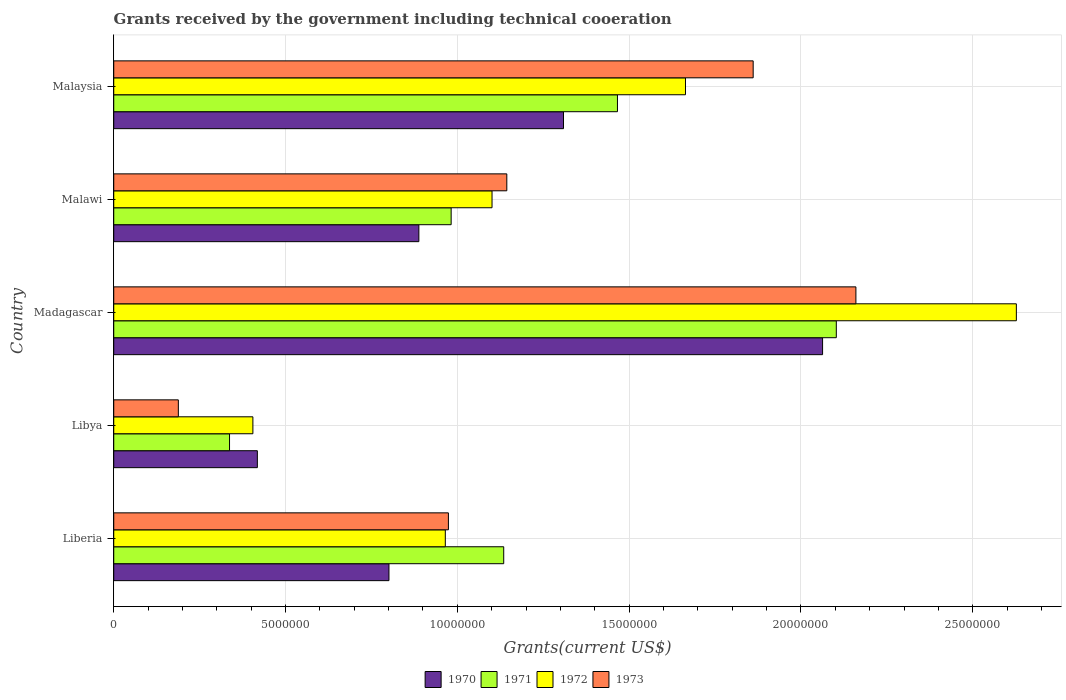Are the number of bars on each tick of the Y-axis equal?
Make the answer very short. Yes. How many bars are there on the 1st tick from the top?
Offer a very short reply. 4. How many bars are there on the 5th tick from the bottom?
Offer a very short reply. 4. What is the label of the 2nd group of bars from the top?
Your response must be concise. Malawi. What is the total grants received by the government in 1970 in Madagascar?
Provide a short and direct response. 2.06e+07. Across all countries, what is the maximum total grants received by the government in 1971?
Your answer should be very brief. 2.10e+07. Across all countries, what is the minimum total grants received by the government in 1972?
Offer a very short reply. 4.05e+06. In which country was the total grants received by the government in 1970 maximum?
Offer a very short reply. Madagascar. In which country was the total grants received by the government in 1972 minimum?
Offer a terse response. Libya. What is the total total grants received by the government in 1970 in the graph?
Make the answer very short. 5.48e+07. What is the difference between the total grants received by the government in 1971 in Liberia and that in Malaysia?
Provide a short and direct response. -3.31e+06. What is the difference between the total grants received by the government in 1971 in Malaysia and the total grants received by the government in 1973 in Liberia?
Offer a terse response. 4.92e+06. What is the average total grants received by the government in 1973 per country?
Your answer should be very brief. 1.27e+07. What is the difference between the total grants received by the government in 1972 and total grants received by the government in 1973 in Malaysia?
Give a very brief answer. -1.97e+06. In how many countries, is the total grants received by the government in 1972 greater than 6000000 US$?
Keep it short and to the point. 4. What is the ratio of the total grants received by the government in 1972 in Liberia to that in Madagascar?
Offer a very short reply. 0.37. What is the difference between the highest and the second highest total grants received by the government in 1970?
Your response must be concise. 7.54e+06. What is the difference between the highest and the lowest total grants received by the government in 1970?
Offer a terse response. 1.64e+07. Is the sum of the total grants received by the government in 1971 in Malawi and Malaysia greater than the maximum total grants received by the government in 1973 across all countries?
Your answer should be very brief. Yes. Is it the case that in every country, the sum of the total grants received by the government in 1971 and total grants received by the government in 1970 is greater than the total grants received by the government in 1972?
Your answer should be very brief. Yes. Are all the bars in the graph horizontal?
Your answer should be very brief. Yes. What is the difference between two consecutive major ticks on the X-axis?
Give a very brief answer. 5.00e+06. Does the graph contain any zero values?
Your answer should be compact. No. Does the graph contain grids?
Your response must be concise. Yes. Where does the legend appear in the graph?
Provide a short and direct response. Bottom center. How many legend labels are there?
Offer a very short reply. 4. What is the title of the graph?
Ensure brevity in your answer.  Grants received by the government including technical cooeration. Does "1978" appear as one of the legend labels in the graph?
Offer a terse response. No. What is the label or title of the X-axis?
Keep it short and to the point. Grants(current US$). What is the label or title of the Y-axis?
Your answer should be compact. Country. What is the Grants(current US$) of 1970 in Liberia?
Provide a succinct answer. 8.01e+06. What is the Grants(current US$) of 1971 in Liberia?
Offer a very short reply. 1.14e+07. What is the Grants(current US$) in 1972 in Liberia?
Keep it short and to the point. 9.65e+06. What is the Grants(current US$) of 1973 in Liberia?
Provide a succinct answer. 9.74e+06. What is the Grants(current US$) of 1970 in Libya?
Provide a succinct answer. 4.18e+06. What is the Grants(current US$) in 1971 in Libya?
Provide a short and direct response. 3.37e+06. What is the Grants(current US$) of 1972 in Libya?
Offer a very short reply. 4.05e+06. What is the Grants(current US$) of 1973 in Libya?
Offer a very short reply. 1.88e+06. What is the Grants(current US$) in 1970 in Madagascar?
Your response must be concise. 2.06e+07. What is the Grants(current US$) in 1971 in Madagascar?
Offer a very short reply. 2.10e+07. What is the Grants(current US$) of 1972 in Madagascar?
Provide a succinct answer. 2.63e+07. What is the Grants(current US$) of 1973 in Madagascar?
Make the answer very short. 2.16e+07. What is the Grants(current US$) in 1970 in Malawi?
Ensure brevity in your answer.  8.88e+06. What is the Grants(current US$) of 1971 in Malawi?
Your answer should be compact. 9.82e+06. What is the Grants(current US$) in 1972 in Malawi?
Offer a terse response. 1.10e+07. What is the Grants(current US$) of 1973 in Malawi?
Offer a very short reply. 1.14e+07. What is the Grants(current US$) of 1970 in Malaysia?
Your response must be concise. 1.31e+07. What is the Grants(current US$) in 1971 in Malaysia?
Give a very brief answer. 1.47e+07. What is the Grants(current US$) of 1972 in Malaysia?
Keep it short and to the point. 1.66e+07. What is the Grants(current US$) of 1973 in Malaysia?
Offer a very short reply. 1.86e+07. Across all countries, what is the maximum Grants(current US$) in 1970?
Provide a short and direct response. 2.06e+07. Across all countries, what is the maximum Grants(current US$) of 1971?
Provide a short and direct response. 2.10e+07. Across all countries, what is the maximum Grants(current US$) in 1972?
Give a very brief answer. 2.63e+07. Across all countries, what is the maximum Grants(current US$) in 1973?
Offer a very short reply. 2.16e+07. Across all countries, what is the minimum Grants(current US$) of 1970?
Give a very brief answer. 4.18e+06. Across all countries, what is the minimum Grants(current US$) in 1971?
Give a very brief answer. 3.37e+06. Across all countries, what is the minimum Grants(current US$) in 1972?
Provide a succinct answer. 4.05e+06. Across all countries, what is the minimum Grants(current US$) of 1973?
Your answer should be very brief. 1.88e+06. What is the total Grants(current US$) of 1970 in the graph?
Your answer should be compact. 5.48e+07. What is the total Grants(current US$) in 1971 in the graph?
Offer a very short reply. 6.02e+07. What is the total Grants(current US$) in 1972 in the graph?
Provide a succinct answer. 6.76e+07. What is the total Grants(current US$) of 1973 in the graph?
Offer a very short reply. 6.33e+07. What is the difference between the Grants(current US$) of 1970 in Liberia and that in Libya?
Offer a very short reply. 3.83e+06. What is the difference between the Grants(current US$) in 1971 in Liberia and that in Libya?
Provide a short and direct response. 7.98e+06. What is the difference between the Grants(current US$) of 1972 in Liberia and that in Libya?
Your answer should be very brief. 5.60e+06. What is the difference between the Grants(current US$) in 1973 in Liberia and that in Libya?
Your answer should be very brief. 7.86e+06. What is the difference between the Grants(current US$) of 1970 in Liberia and that in Madagascar?
Offer a very short reply. -1.26e+07. What is the difference between the Grants(current US$) in 1971 in Liberia and that in Madagascar?
Keep it short and to the point. -9.68e+06. What is the difference between the Grants(current US$) of 1972 in Liberia and that in Madagascar?
Ensure brevity in your answer.  -1.66e+07. What is the difference between the Grants(current US$) of 1973 in Liberia and that in Madagascar?
Your response must be concise. -1.19e+07. What is the difference between the Grants(current US$) in 1970 in Liberia and that in Malawi?
Keep it short and to the point. -8.70e+05. What is the difference between the Grants(current US$) of 1971 in Liberia and that in Malawi?
Provide a succinct answer. 1.53e+06. What is the difference between the Grants(current US$) of 1972 in Liberia and that in Malawi?
Give a very brief answer. -1.36e+06. What is the difference between the Grants(current US$) in 1973 in Liberia and that in Malawi?
Provide a succinct answer. -1.70e+06. What is the difference between the Grants(current US$) in 1970 in Liberia and that in Malaysia?
Provide a succinct answer. -5.08e+06. What is the difference between the Grants(current US$) in 1971 in Liberia and that in Malaysia?
Offer a very short reply. -3.31e+06. What is the difference between the Grants(current US$) in 1972 in Liberia and that in Malaysia?
Your response must be concise. -6.99e+06. What is the difference between the Grants(current US$) in 1973 in Liberia and that in Malaysia?
Offer a terse response. -8.87e+06. What is the difference between the Grants(current US$) in 1970 in Libya and that in Madagascar?
Offer a terse response. -1.64e+07. What is the difference between the Grants(current US$) of 1971 in Libya and that in Madagascar?
Give a very brief answer. -1.77e+07. What is the difference between the Grants(current US$) of 1972 in Libya and that in Madagascar?
Offer a terse response. -2.22e+07. What is the difference between the Grants(current US$) of 1973 in Libya and that in Madagascar?
Your answer should be very brief. -1.97e+07. What is the difference between the Grants(current US$) in 1970 in Libya and that in Malawi?
Provide a short and direct response. -4.70e+06. What is the difference between the Grants(current US$) of 1971 in Libya and that in Malawi?
Your answer should be compact. -6.45e+06. What is the difference between the Grants(current US$) in 1972 in Libya and that in Malawi?
Your answer should be compact. -6.96e+06. What is the difference between the Grants(current US$) of 1973 in Libya and that in Malawi?
Offer a very short reply. -9.56e+06. What is the difference between the Grants(current US$) of 1970 in Libya and that in Malaysia?
Keep it short and to the point. -8.91e+06. What is the difference between the Grants(current US$) of 1971 in Libya and that in Malaysia?
Keep it short and to the point. -1.13e+07. What is the difference between the Grants(current US$) in 1972 in Libya and that in Malaysia?
Keep it short and to the point. -1.26e+07. What is the difference between the Grants(current US$) of 1973 in Libya and that in Malaysia?
Keep it short and to the point. -1.67e+07. What is the difference between the Grants(current US$) of 1970 in Madagascar and that in Malawi?
Keep it short and to the point. 1.18e+07. What is the difference between the Grants(current US$) of 1971 in Madagascar and that in Malawi?
Keep it short and to the point. 1.12e+07. What is the difference between the Grants(current US$) of 1972 in Madagascar and that in Malawi?
Your answer should be compact. 1.53e+07. What is the difference between the Grants(current US$) of 1973 in Madagascar and that in Malawi?
Make the answer very short. 1.02e+07. What is the difference between the Grants(current US$) in 1970 in Madagascar and that in Malaysia?
Your answer should be compact. 7.54e+06. What is the difference between the Grants(current US$) in 1971 in Madagascar and that in Malaysia?
Offer a terse response. 6.37e+06. What is the difference between the Grants(current US$) of 1972 in Madagascar and that in Malaysia?
Provide a short and direct response. 9.63e+06. What is the difference between the Grants(current US$) in 1973 in Madagascar and that in Malaysia?
Offer a terse response. 2.99e+06. What is the difference between the Grants(current US$) in 1970 in Malawi and that in Malaysia?
Offer a very short reply. -4.21e+06. What is the difference between the Grants(current US$) in 1971 in Malawi and that in Malaysia?
Keep it short and to the point. -4.84e+06. What is the difference between the Grants(current US$) in 1972 in Malawi and that in Malaysia?
Offer a very short reply. -5.63e+06. What is the difference between the Grants(current US$) of 1973 in Malawi and that in Malaysia?
Your answer should be very brief. -7.17e+06. What is the difference between the Grants(current US$) of 1970 in Liberia and the Grants(current US$) of 1971 in Libya?
Your answer should be compact. 4.64e+06. What is the difference between the Grants(current US$) of 1970 in Liberia and the Grants(current US$) of 1972 in Libya?
Your answer should be compact. 3.96e+06. What is the difference between the Grants(current US$) in 1970 in Liberia and the Grants(current US$) in 1973 in Libya?
Provide a short and direct response. 6.13e+06. What is the difference between the Grants(current US$) in 1971 in Liberia and the Grants(current US$) in 1972 in Libya?
Give a very brief answer. 7.30e+06. What is the difference between the Grants(current US$) of 1971 in Liberia and the Grants(current US$) of 1973 in Libya?
Provide a short and direct response. 9.47e+06. What is the difference between the Grants(current US$) in 1972 in Liberia and the Grants(current US$) in 1973 in Libya?
Your answer should be compact. 7.77e+06. What is the difference between the Grants(current US$) in 1970 in Liberia and the Grants(current US$) in 1971 in Madagascar?
Your answer should be compact. -1.30e+07. What is the difference between the Grants(current US$) of 1970 in Liberia and the Grants(current US$) of 1972 in Madagascar?
Your response must be concise. -1.83e+07. What is the difference between the Grants(current US$) of 1970 in Liberia and the Grants(current US$) of 1973 in Madagascar?
Make the answer very short. -1.36e+07. What is the difference between the Grants(current US$) in 1971 in Liberia and the Grants(current US$) in 1972 in Madagascar?
Your answer should be compact. -1.49e+07. What is the difference between the Grants(current US$) of 1971 in Liberia and the Grants(current US$) of 1973 in Madagascar?
Your response must be concise. -1.02e+07. What is the difference between the Grants(current US$) of 1972 in Liberia and the Grants(current US$) of 1973 in Madagascar?
Provide a succinct answer. -1.20e+07. What is the difference between the Grants(current US$) in 1970 in Liberia and the Grants(current US$) in 1971 in Malawi?
Provide a short and direct response. -1.81e+06. What is the difference between the Grants(current US$) in 1970 in Liberia and the Grants(current US$) in 1973 in Malawi?
Offer a very short reply. -3.43e+06. What is the difference between the Grants(current US$) in 1971 in Liberia and the Grants(current US$) in 1972 in Malawi?
Make the answer very short. 3.40e+05. What is the difference between the Grants(current US$) of 1971 in Liberia and the Grants(current US$) of 1973 in Malawi?
Your answer should be very brief. -9.00e+04. What is the difference between the Grants(current US$) of 1972 in Liberia and the Grants(current US$) of 1973 in Malawi?
Provide a short and direct response. -1.79e+06. What is the difference between the Grants(current US$) in 1970 in Liberia and the Grants(current US$) in 1971 in Malaysia?
Provide a short and direct response. -6.65e+06. What is the difference between the Grants(current US$) in 1970 in Liberia and the Grants(current US$) in 1972 in Malaysia?
Your answer should be very brief. -8.63e+06. What is the difference between the Grants(current US$) in 1970 in Liberia and the Grants(current US$) in 1973 in Malaysia?
Ensure brevity in your answer.  -1.06e+07. What is the difference between the Grants(current US$) of 1971 in Liberia and the Grants(current US$) of 1972 in Malaysia?
Your answer should be very brief. -5.29e+06. What is the difference between the Grants(current US$) in 1971 in Liberia and the Grants(current US$) in 1973 in Malaysia?
Your answer should be very brief. -7.26e+06. What is the difference between the Grants(current US$) of 1972 in Liberia and the Grants(current US$) of 1973 in Malaysia?
Provide a succinct answer. -8.96e+06. What is the difference between the Grants(current US$) in 1970 in Libya and the Grants(current US$) in 1971 in Madagascar?
Offer a terse response. -1.68e+07. What is the difference between the Grants(current US$) in 1970 in Libya and the Grants(current US$) in 1972 in Madagascar?
Make the answer very short. -2.21e+07. What is the difference between the Grants(current US$) of 1970 in Libya and the Grants(current US$) of 1973 in Madagascar?
Provide a succinct answer. -1.74e+07. What is the difference between the Grants(current US$) of 1971 in Libya and the Grants(current US$) of 1972 in Madagascar?
Your answer should be compact. -2.29e+07. What is the difference between the Grants(current US$) of 1971 in Libya and the Grants(current US$) of 1973 in Madagascar?
Give a very brief answer. -1.82e+07. What is the difference between the Grants(current US$) in 1972 in Libya and the Grants(current US$) in 1973 in Madagascar?
Offer a terse response. -1.76e+07. What is the difference between the Grants(current US$) of 1970 in Libya and the Grants(current US$) of 1971 in Malawi?
Provide a short and direct response. -5.64e+06. What is the difference between the Grants(current US$) of 1970 in Libya and the Grants(current US$) of 1972 in Malawi?
Your answer should be very brief. -6.83e+06. What is the difference between the Grants(current US$) in 1970 in Libya and the Grants(current US$) in 1973 in Malawi?
Keep it short and to the point. -7.26e+06. What is the difference between the Grants(current US$) of 1971 in Libya and the Grants(current US$) of 1972 in Malawi?
Offer a terse response. -7.64e+06. What is the difference between the Grants(current US$) in 1971 in Libya and the Grants(current US$) in 1973 in Malawi?
Provide a short and direct response. -8.07e+06. What is the difference between the Grants(current US$) of 1972 in Libya and the Grants(current US$) of 1973 in Malawi?
Keep it short and to the point. -7.39e+06. What is the difference between the Grants(current US$) in 1970 in Libya and the Grants(current US$) in 1971 in Malaysia?
Give a very brief answer. -1.05e+07. What is the difference between the Grants(current US$) of 1970 in Libya and the Grants(current US$) of 1972 in Malaysia?
Your answer should be very brief. -1.25e+07. What is the difference between the Grants(current US$) of 1970 in Libya and the Grants(current US$) of 1973 in Malaysia?
Offer a terse response. -1.44e+07. What is the difference between the Grants(current US$) of 1971 in Libya and the Grants(current US$) of 1972 in Malaysia?
Your response must be concise. -1.33e+07. What is the difference between the Grants(current US$) of 1971 in Libya and the Grants(current US$) of 1973 in Malaysia?
Ensure brevity in your answer.  -1.52e+07. What is the difference between the Grants(current US$) of 1972 in Libya and the Grants(current US$) of 1973 in Malaysia?
Provide a short and direct response. -1.46e+07. What is the difference between the Grants(current US$) of 1970 in Madagascar and the Grants(current US$) of 1971 in Malawi?
Offer a terse response. 1.08e+07. What is the difference between the Grants(current US$) in 1970 in Madagascar and the Grants(current US$) in 1972 in Malawi?
Provide a short and direct response. 9.62e+06. What is the difference between the Grants(current US$) of 1970 in Madagascar and the Grants(current US$) of 1973 in Malawi?
Ensure brevity in your answer.  9.19e+06. What is the difference between the Grants(current US$) of 1971 in Madagascar and the Grants(current US$) of 1972 in Malawi?
Your response must be concise. 1.00e+07. What is the difference between the Grants(current US$) of 1971 in Madagascar and the Grants(current US$) of 1973 in Malawi?
Offer a very short reply. 9.59e+06. What is the difference between the Grants(current US$) of 1972 in Madagascar and the Grants(current US$) of 1973 in Malawi?
Make the answer very short. 1.48e+07. What is the difference between the Grants(current US$) of 1970 in Madagascar and the Grants(current US$) of 1971 in Malaysia?
Your answer should be very brief. 5.97e+06. What is the difference between the Grants(current US$) of 1970 in Madagascar and the Grants(current US$) of 1972 in Malaysia?
Your response must be concise. 3.99e+06. What is the difference between the Grants(current US$) of 1970 in Madagascar and the Grants(current US$) of 1973 in Malaysia?
Provide a short and direct response. 2.02e+06. What is the difference between the Grants(current US$) of 1971 in Madagascar and the Grants(current US$) of 1972 in Malaysia?
Make the answer very short. 4.39e+06. What is the difference between the Grants(current US$) of 1971 in Madagascar and the Grants(current US$) of 1973 in Malaysia?
Offer a terse response. 2.42e+06. What is the difference between the Grants(current US$) of 1972 in Madagascar and the Grants(current US$) of 1973 in Malaysia?
Offer a very short reply. 7.66e+06. What is the difference between the Grants(current US$) of 1970 in Malawi and the Grants(current US$) of 1971 in Malaysia?
Give a very brief answer. -5.78e+06. What is the difference between the Grants(current US$) in 1970 in Malawi and the Grants(current US$) in 1972 in Malaysia?
Your answer should be compact. -7.76e+06. What is the difference between the Grants(current US$) of 1970 in Malawi and the Grants(current US$) of 1973 in Malaysia?
Give a very brief answer. -9.73e+06. What is the difference between the Grants(current US$) of 1971 in Malawi and the Grants(current US$) of 1972 in Malaysia?
Your answer should be compact. -6.82e+06. What is the difference between the Grants(current US$) in 1971 in Malawi and the Grants(current US$) in 1973 in Malaysia?
Ensure brevity in your answer.  -8.79e+06. What is the difference between the Grants(current US$) of 1972 in Malawi and the Grants(current US$) of 1973 in Malaysia?
Keep it short and to the point. -7.60e+06. What is the average Grants(current US$) of 1970 per country?
Ensure brevity in your answer.  1.10e+07. What is the average Grants(current US$) in 1971 per country?
Ensure brevity in your answer.  1.20e+07. What is the average Grants(current US$) in 1972 per country?
Your answer should be compact. 1.35e+07. What is the average Grants(current US$) in 1973 per country?
Ensure brevity in your answer.  1.27e+07. What is the difference between the Grants(current US$) in 1970 and Grants(current US$) in 1971 in Liberia?
Make the answer very short. -3.34e+06. What is the difference between the Grants(current US$) of 1970 and Grants(current US$) of 1972 in Liberia?
Your answer should be compact. -1.64e+06. What is the difference between the Grants(current US$) in 1970 and Grants(current US$) in 1973 in Liberia?
Make the answer very short. -1.73e+06. What is the difference between the Grants(current US$) in 1971 and Grants(current US$) in 1972 in Liberia?
Your answer should be compact. 1.70e+06. What is the difference between the Grants(current US$) in 1971 and Grants(current US$) in 1973 in Liberia?
Your answer should be very brief. 1.61e+06. What is the difference between the Grants(current US$) of 1970 and Grants(current US$) of 1971 in Libya?
Ensure brevity in your answer.  8.10e+05. What is the difference between the Grants(current US$) in 1970 and Grants(current US$) in 1972 in Libya?
Provide a succinct answer. 1.30e+05. What is the difference between the Grants(current US$) in 1970 and Grants(current US$) in 1973 in Libya?
Ensure brevity in your answer.  2.30e+06. What is the difference between the Grants(current US$) in 1971 and Grants(current US$) in 1972 in Libya?
Your answer should be very brief. -6.80e+05. What is the difference between the Grants(current US$) in 1971 and Grants(current US$) in 1973 in Libya?
Your answer should be very brief. 1.49e+06. What is the difference between the Grants(current US$) of 1972 and Grants(current US$) of 1973 in Libya?
Your response must be concise. 2.17e+06. What is the difference between the Grants(current US$) in 1970 and Grants(current US$) in 1971 in Madagascar?
Offer a very short reply. -4.00e+05. What is the difference between the Grants(current US$) in 1970 and Grants(current US$) in 1972 in Madagascar?
Offer a terse response. -5.64e+06. What is the difference between the Grants(current US$) of 1970 and Grants(current US$) of 1973 in Madagascar?
Offer a terse response. -9.70e+05. What is the difference between the Grants(current US$) of 1971 and Grants(current US$) of 1972 in Madagascar?
Make the answer very short. -5.24e+06. What is the difference between the Grants(current US$) of 1971 and Grants(current US$) of 1973 in Madagascar?
Ensure brevity in your answer.  -5.70e+05. What is the difference between the Grants(current US$) of 1972 and Grants(current US$) of 1973 in Madagascar?
Make the answer very short. 4.67e+06. What is the difference between the Grants(current US$) of 1970 and Grants(current US$) of 1971 in Malawi?
Your response must be concise. -9.40e+05. What is the difference between the Grants(current US$) in 1970 and Grants(current US$) in 1972 in Malawi?
Ensure brevity in your answer.  -2.13e+06. What is the difference between the Grants(current US$) of 1970 and Grants(current US$) of 1973 in Malawi?
Your answer should be compact. -2.56e+06. What is the difference between the Grants(current US$) of 1971 and Grants(current US$) of 1972 in Malawi?
Your answer should be compact. -1.19e+06. What is the difference between the Grants(current US$) in 1971 and Grants(current US$) in 1973 in Malawi?
Your answer should be compact. -1.62e+06. What is the difference between the Grants(current US$) in 1972 and Grants(current US$) in 1973 in Malawi?
Your answer should be very brief. -4.30e+05. What is the difference between the Grants(current US$) of 1970 and Grants(current US$) of 1971 in Malaysia?
Keep it short and to the point. -1.57e+06. What is the difference between the Grants(current US$) of 1970 and Grants(current US$) of 1972 in Malaysia?
Offer a terse response. -3.55e+06. What is the difference between the Grants(current US$) of 1970 and Grants(current US$) of 1973 in Malaysia?
Your answer should be very brief. -5.52e+06. What is the difference between the Grants(current US$) in 1971 and Grants(current US$) in 1972 in Malaysia?
Your answer should be compact. -1.98e+06. What is the difference between the Grants(current US$) in 1971 and Grants(current US$) in 1973 in Malaysia?
Your response must be concise. -3.95e+06. What is the difference between the Grants(current US$) in 1972 and Grants(current US$) in 1973 in Malaysia?
Your answer should be compact. -1.97e+06. What is the ratio of the Grants(current US$) in 1970 in Liberia to that in Libya?
Ensure brevity in your answer.  1.92. What is the ratio of the Grants(current US$) of 1971 in Liberia to that in Libya?
Ensure brevity in your answer.  3.37. What is the ratio of the Grants(current US$) in 1972 in Liberia to that in Libya?
Offer a terse response. 2.38. What is the ratio of the Grants(current US$) of 1973 in Liberia to that in Libya?
Your answer should be very brief. 5.18. What is the ratio of the Grants(current US$) of 1970 in Liberia to that in Madagascar?
Your response must be concise. 0.39. What is the ratio of the Grants(current US$) in 1971 in Liberia to that in Madagascar?
Provide a short and direct response. 0.54. What is the ratio of the Grants(current US$) in 1972 in Liberia to that in Madagascar?
Offer a very short reply. 0.37. What is the ratio of the Grants(current US$) in 1973 in Liberia to that in Madagascar?
Your response must be concise. 0.45. What is the ratio of the Grants(current US$) in 1970 in Liberia to that in Malawi?
Your response must be concise. 0.9. What is the ratio of the Grants(current US$) of 1971 in Liberia to that in Malawi?
Provide a short and direct response. 1.16. What is the ratio of the Grants(current US$) in 1972 in Liberia to that in Malawi?
Keep it short and to the point. 0.88. What is the ratio of the Grants(current US$) of 1973 in Liberia to that in Malawi?
Make the answer very short. 0.85. What is the ratio of the Grants(current US$) in 1970 in Liberia to that in Malaysia?
Your response must be concise. 0.61. What is the ratio of the Grants(current US$) of 1971 in Liberia to that in Malaysia?
Provide a short and direct response. 0.77. What is the ratio of the Grants(current US$) in 1972 in Liberia to that in Malaysia?
Make the answer very short. 0.58. What is the ratio of the Grants(current US$) in 1973 in Liberia to that in Malaysia?
Offer a terse response. 0.52. What is the ratio of the Grants(current US$) in 1970 in Libya to that in Madagascar?
Your answer should be compact. 0.2. What is the ratio of the Grants(current US$) in 1971 in Libya to that in Madagascar?
Offer a terse response. 0.16. What is the ratio of the Grants(current US$) in 1972 in Libya to that in Madagascar?
Give a very brief answer. 0.15. What is the ratio of the Grants(current US$) of 1973 in Libya to that in Madagascar?
Give a very brief answer. 0.09. What is the ratio of the Grants(current US$) of 1970 in Libya to that in Malawi?
Offer a very short reply. 0.47. What is the ratio of the Grants(current US$) in 1971 in Libya to that in Malawi?
Provide a short and direct response. 0.34. What is the ratio of the Grants(current US$) of 1972 in Libya to that in Malawi?
Ensure brevity in your answer.  0.37. What is the ratio of the Grants(current US$) of 1973 in Libya to that in Malawi?
Your answer should be very brief. 0.16. What is the ratio of the Grants(current US$) of 1970 in Libya to that in Malaysia?
Your answer should be very brief. 0.32. What is the ratio of the Grants(current US$) of 1971 in Libya to that in Malaysia?
Provide a succinct answer. 0.23. What is the ratio of the Grants(current US$) of 1972 in Libya to that in Malaysia?
Give a very brief answer. 0.24. What is the ratio of the Grants(current US$) of 1973 in Libya to that in Malaysia?
Your response must be concise. 0.1. What is the ratio of the Grants(current US$) in 1970 in Madagascar to that in Malawi?
Provide a short and direct response. 2.32. What is the ratio of the Grants(current US$) of 1971 in Madagascar to that in Malawi?
Offer a terse response. 2.14. What is the ratio of the Grants(current US$) of 1972 in Madagascar to that in Malawi?
Give a very brief answer. 2.39. What is the ratio of the Grants(current US$) of 1973 in Madagascar to that in Malawi?
Ensure brevity in your answer.  1.89. What is the ratio of the Grants(current US$) of 1970 in Madagascar to that in Malaysia?
Offer a very short reply. 1.58. What is the ratio of the Grants(current US$) in 1971 in Madagascar to that in Malaysia?
Provide a short and direct response. 1.43. What is the ratio of the Grants(current US$) of 1972 in Madagascar to that in Malaysia?
Offer a terse response. 1.58. What is the ratio of the Grants(current US$) in 1973 in Madagascar to that in Malaysia?
Provide a short and direct response. 1.16. What is the ratio of the Grants(current US$) of 1970 in Malawi to that in Malaysia?
Your answer should be very brief. 0.68. What is the ratio of the Grants(current US$) in 1971 in Malawi to that in Malaysia?
Offer a terse response. 0.67. What is the ratio of the Grants(current US$) of 1972 in Malawi to that in Malaysia?
Your answer should be very brief. 0.66. What is the ratio of the Grants(current US$) of 1973 in Malawi to that in Malaysia?
Your answer should be compact. 0.61. What is the difference between the highest and the second highest Grants(current US$) in 1970?
Provide a succinct answer. 7.54e+06. What is the difference between the highest and the second highest Grants(current US$) in 1971?
Offer a very short reply. 6.37e+06. What is the difference between the highest and the second highest Grants(current US$) of 1972?
Your answer should be compact. 9.63e+06. What is the difference between the highest and the second highest Grants(current US$) of 1973?
Your answer should be very brief. 2.99e+06. What is the difference between the highest and the lowest Grants(current US$) of 1970?
Offer a terse response. 1.64e+07. What is the difference between the highest and the lowest Grants(current US$) of 1971?
Ensure brevity in your answer.  1.77e+07. What is the difference between the highest and the lowest Grants(current US$) of 1972?
Ensure brevity in your answer.  2.22e+07. What is the difference between the highest and the lowest Grants(current US$) in 1973?
Make the answer very short. 1.97e+07. 